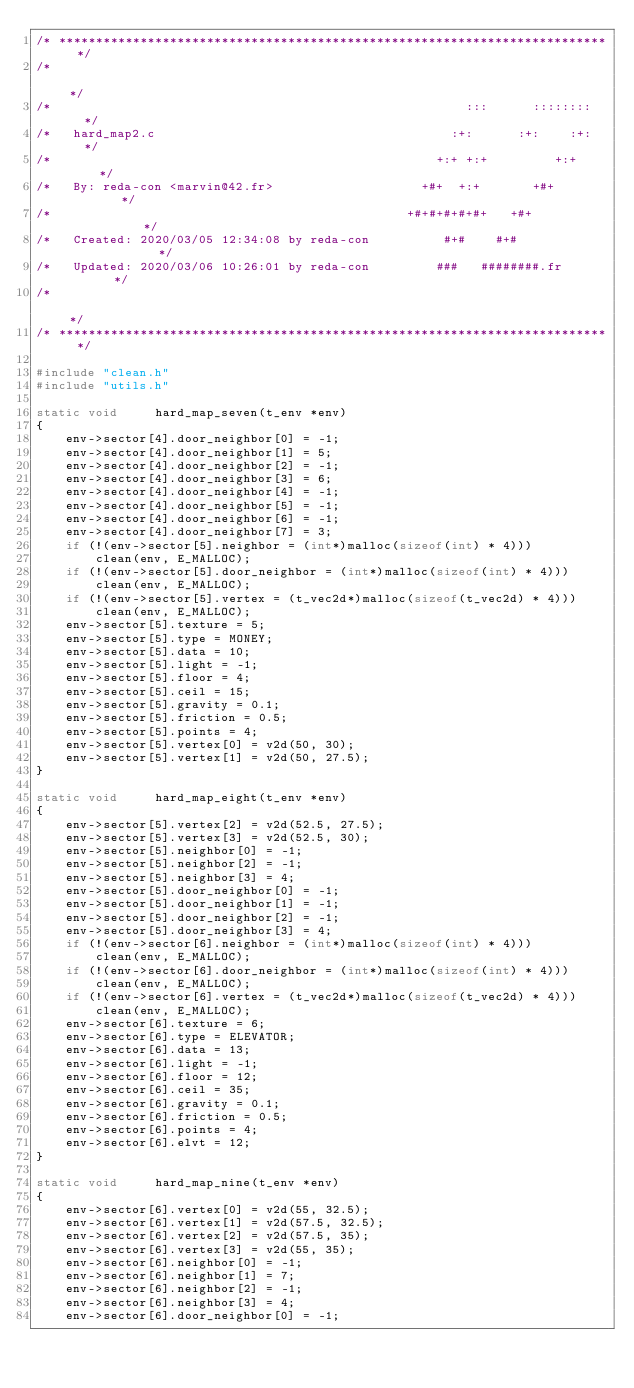Convert code to text. <code><loc_0><loc_0><loc_500><loc_500><_C_>/* ************************************************************************** */
/*                                                                            */
/*                                                        :::      ::::::::   */
/*   hard_map2.c                                        :+:      :+:    :+:   */
/*                                                    +:+ +:+         +:+     */
/*   By: reda-con <marvin@42.fr>                    +#+  +:+       +#+        */
/*                                                +#+#+#+#+#+   +#+           */
/*   Created: 2020/03/05 12:34:08 by reda-con          #+#    #+#             */
/*   Updated: 2020/03/06 10:26:01 by reda-con         ###   ########.fr       */
/*                                                                            */
/* ************************************************************************** */

#include "clean.h"
#include "utils.h"

static void		hard_map_seven(t_env *env)
{
	env->sector[4].door_neighbor[0] = -1;
	env->sector[4].door_neighbor[1] = 5;
	env->sector[4].door_neighbor[2] = -1;
	env->sector[4].door_neighbor[3] = 6;
	env->sector[4].door_neighbor[4] = -1;
	env->sector[4].door_neighbor[5] = -1;
	env->sector[4].door_neighbor[6] = -1;
	env->sector[4].door_neighbor[7] = 3;
	if (!(env->sector[5].neighbor = (int*)malloc(sizeof(int) * 4)))
		clean(env, E_MALLOC);
	if (!(env->sector[5].door_neighbor = (int*)malloc(sizeof(int) * 4)))
		clean(env, E_MALLOC);
	if (!(env->sector[5].vertex = (t_vec2d*)malloc(sizeof(t_vec2d) * 4)))
		clean(env, E_MALLOC);
	env->sector[5].texture = 5;
	env->sector[5].type = MONEY;
	env->sector[5].data = 10;
	env->sector[5].light = -1;
	env->sector[5].floor = 4;
	env->sector[5].ceil = 15;
	env->sector[5].gravity = 0.1;
	env->sector[5].friction = 0.5;
	env->sector[5].points = 4;
	env->sector[5].vertex[0] = v2d(50, 30);
	env->sector[5].vertex[1] = v2d(50, 27.5);
}

static void		hard_map_eight(t_env *env)
{
	env->sector[5].vertex[2] = v2d(52.5, 27.5);
	env->sector[5].vertex[3] = v2d(52.5, 30);
	env->sector[5].neighbor[0] = -1;
	env->sector[5].neighbor[2] = -1;
	env->sector[5].neighbor[3] = 4;
	env->sector[5].door_neighbor[0] = -1;
	env->sector[5].door_neighbor[1] = -1;
	env->sector[5].door_neighbor[2] = -1;
	env->sector[5].door_neighbor[3] = 4;
	if (!(env->sector[6].neighbor = (int*)malloc(sizeof(int) * 4)))
		clean(env, E_MALLOC);
	if (!(env->sector[6].door_neighbor = (int*)malloc(sizeof(int) * 4)))
		clean(env, E_MALLOC);
	if (!(env->sector[6].vertex = (t_vec2d*)malloc(sizeof(t_vec2d) * 4)))
		clean(env, E_MALLOC);
	env->sector[6].texture = 6;
	env->sector[6].type = ELEVATOR;
	env->sector[6].data = 13;
	env->sector[6].light = -1;
	env->sector[6].floor = 12;
	env->sector[6].ceil = 35;
	env->sector[6].gravity = 0.1;
	env->sector[6].friction = 0.5;
	env->sector[6].points = 4;
	env->sector[6].elvt = 12;
}

static void		hard_map_nine(t_env *env)
{
	env->sector[6].vertex[0] = v2d(55, 32.5);
	env->sector[6].vertex[1] = v2d(57.5, 32.5);
	env->sector[6].vertex[2] = v2d(57.5, 35);
	env->sector[6].vertex[3] = v2d(55, 35);
	env->sector[6].neighbor[0] = -1;
	env->sector[6].neighbor[1] = 7;
	env->sector[6].neighbor[2] = -1;
	env->sector[6].neighbor[3] = 4;
	env->sector[6].door_neighbor[0] = -1;</code> 